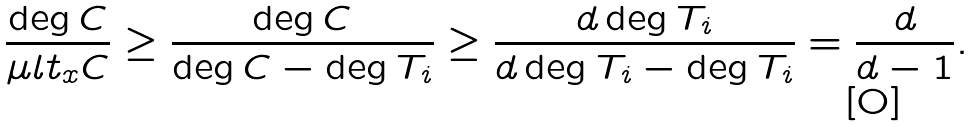Convert formula to latex. <formula><loc_0><loc_0><loc_500><loc_500>\frac { \deg C } { \mu l t _ { x } C } \geq \frac { \deg C } { \deg C - \deg T _ { i } } \geq \frac { d \deg T _ { i } } { d \deg T _ { i } - \deg T _ { i } } = \frac { d } { d - 1 } .</formula> 